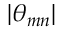<formula> <loc_0><loc_0><loc_500><loc_500>| \theta _ { m n } |</formula> 